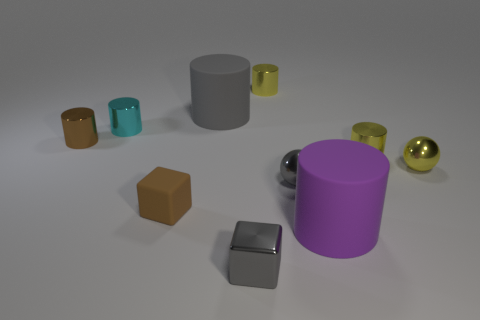Subtract all large cylinders. How many cylinders are left? 4 Subtract all purple spheres. How many yellow cylinders are left? 2 Subtract all brown cylinders. How many cylinders are left? 5 Subtract 2 cylinders. How many cylinders are left? 4 Subtract all cylinders. How many objects are left? 4 Subtract all brown cylinders. Subtract all green balls. How many cylinders are left? 5 Subtract all metal things. Subtract all small gray things. How many objects are left? 1 Add 6 gray blocks. How many gray blocks are left? 7 Add 7 big rubber blocks. How many big rubber blocks exist? 7 Subtract 1 yellow cylinders. How many objects are left? 9 